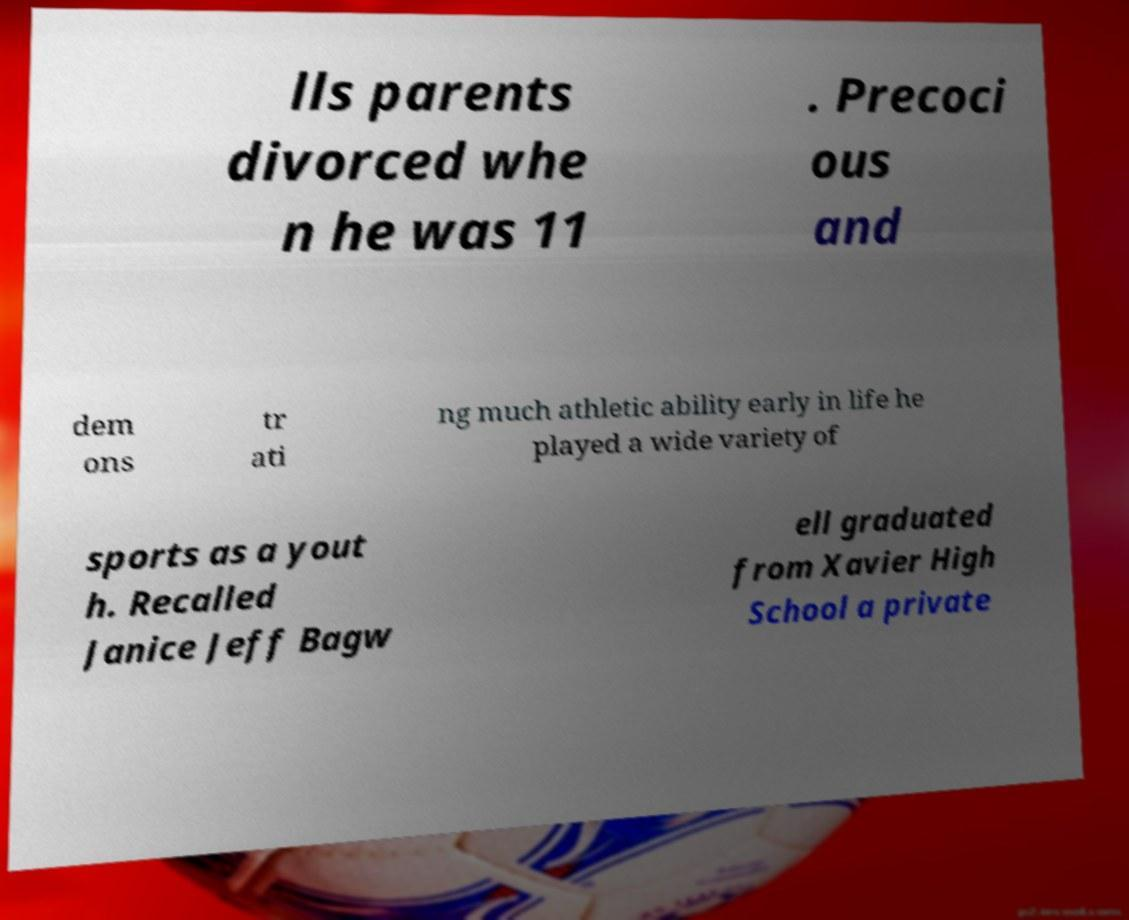Please identify and transcribe the text found in this image. lls parents divorced whe n he was 11 . Precoci ous and dem ons tr ati ng much athletic ability early in life he played a wide variety of sports as a yout h. Recalled Janice Jeff Bagw ell graduated from Xavier High School a private 